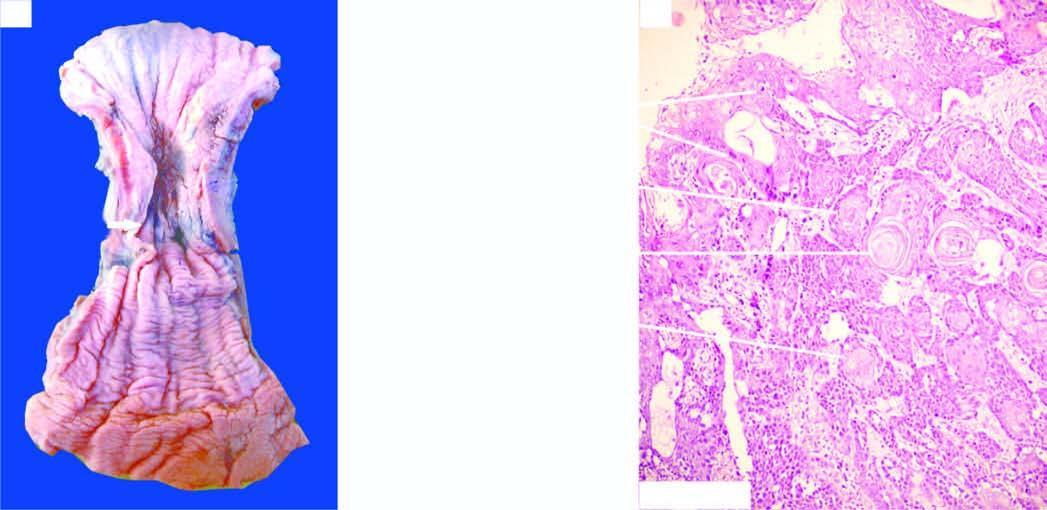what does photomicrograph show?
Answer the question using a single word or phrase. Whorls of anaplastic squamous cells invading the underlying soft tissues 